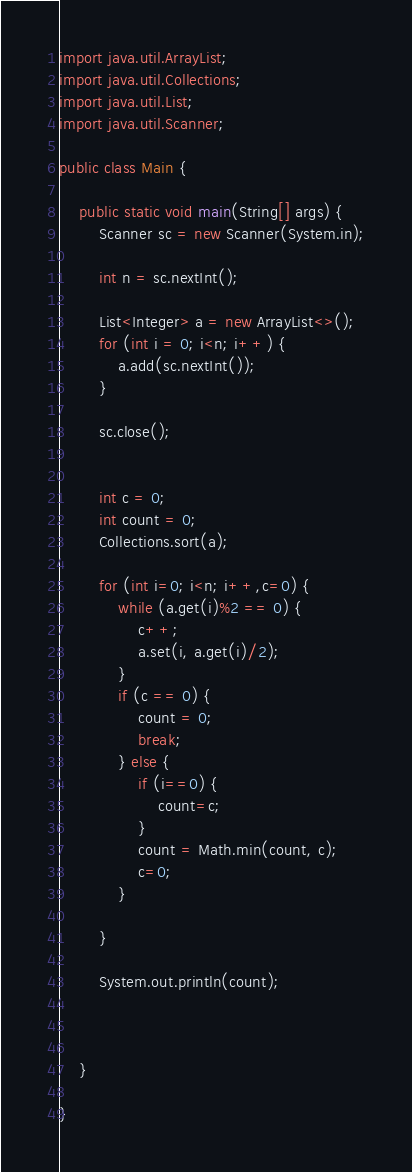<code> <loc_0><loc_0><loc_500><loc_500><_Java_>import java.util.ArrayList;
import java.util.Collections;
import java.util.List;
import java.util.Scanner;

public class Main {

	public static void main(String[] args) {
		Scanner sc = new Scanner(System.in);
		
		int n = sc.nextInt();
		
		List<Integer> a = new ArrayList<>();
		for (int i = 0; i<n; i++) {
			a.add(sc.nextInt());
		}
	
		sc.close();
		
		
		int c = 0;
		int count = 0;
		Collections.sort(a);
		
		for (int i=0; i<n; i++,c=0) {
			while (a.get(i)%2 == 0) {
				c++;
				a.set(i, a.get(i)/2);
			}
			if (c == 0) {
				count = 0;
				break;
			} else {
				if (i==0) {
					count=c;
				}
				count = Math.min(count, c);
		        c=0;
			}
		
		}
		
		System.out.println(count);

		

	}

}
</code> 